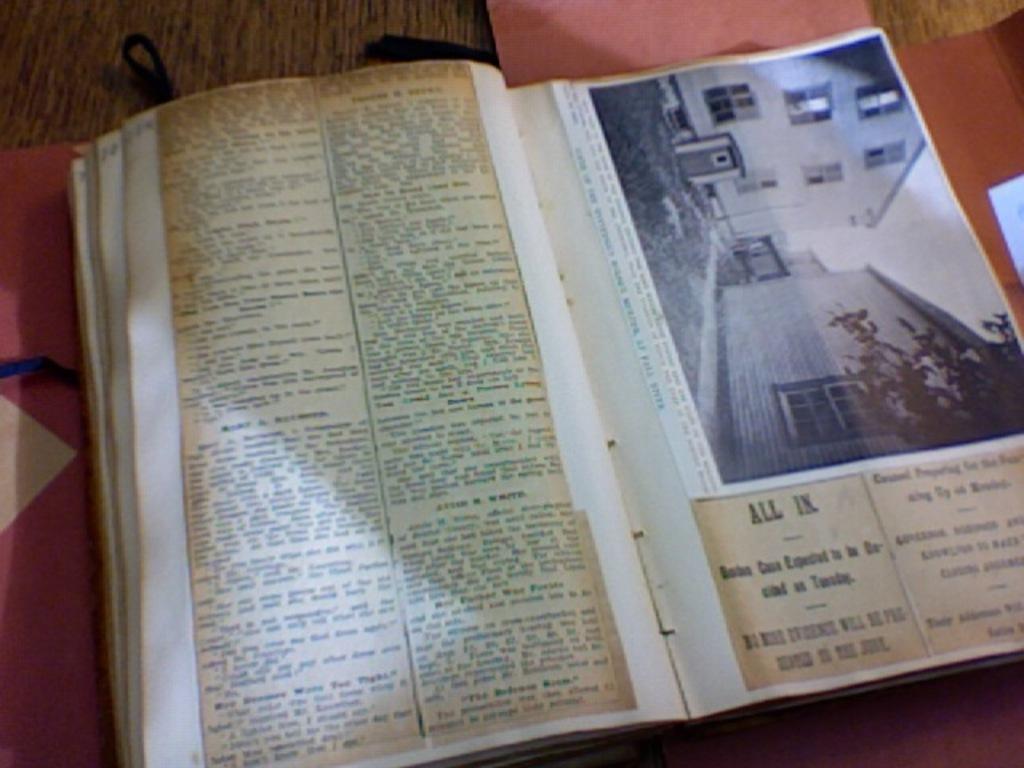Is this a history book?
Provide a succinct answer. Yes. 